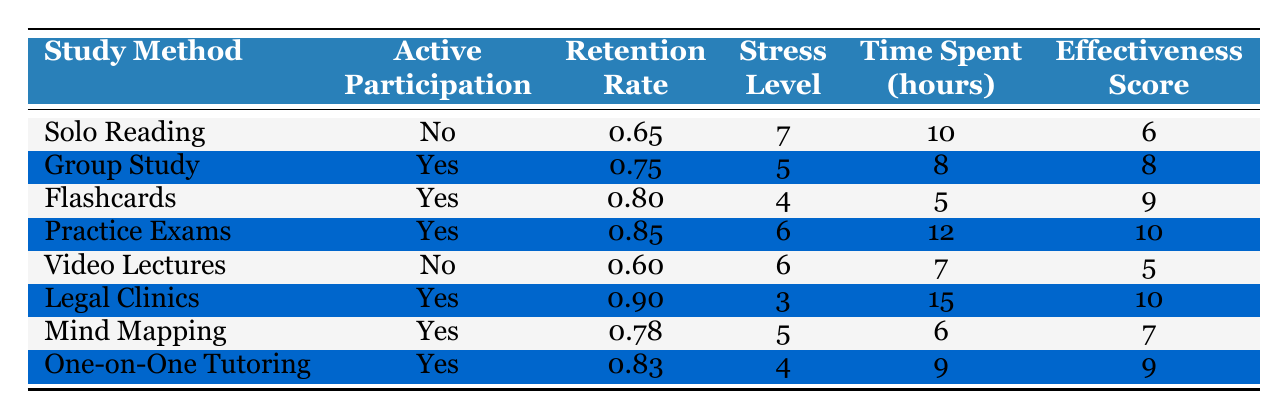What is the retention rate for Group Study? The table shows that for the Group Study method, the retention rate listed is 0.75.
Answer: 0.75 Which study method has the lowest effectiveness score? Looking through the effectiveness scores in the table, Video Lectures have the lowest score at 5.
Answer: 5 Are there more study methods with active participation or without it? From the table, there are 6 methods with active participation (Group Study, Flashcards, Practice Exams, Legal Clinics, Mind Mapping, One-on-One Tutoring) and 2 methods without it (Solo Reading, Video Lectures). Therefore, there are more methods with active participation.
Answer: Yes, there are more methods with active participation What is the total time spent on practice exams and legal clinics? The time spent on Practice Exams is 12 hours and on Legal Clinics is 15 hours. Adding these together gives us 12 + 15 = 27 hours total.
Answer: 27 hours What is the average stress level of study methods that involve active participation? The stress levels for methods with active participation are 5 (Group Study), 4 (Flashcards), 6 (Practice Exams), 3 (Legal Clinics), 5 (Mind Mapping), and 4 (One-on-One Tutoring). Adding these together (5 + 4 + 6 + 3 + 5 + 4 = 27) and dividing by 6 (the number of methods) gives an average of 27 / 6 = 4.5.
Answer: 4.5 Which study method has the highest retention rate and what is that rate? The table lists retention rates for each method, and the highest is 0.90 for Legal Clinics.
Answer: 0.90 Is the stress level for Flashcards lower than that for Solo Reading? The stress level for Flashcards is 4, while for Solo Reading, it is 7. Since 4 is less than 7, the statement is true.
Answer: Yes Which study method offers the best effectiveness score while keeping the stress level below 5? Looking through the table, the highest effectiveness score with a stress level below 5 is for Flashcards, which has a score of 9 and a stress level of 4.
Answer: Flashcards 